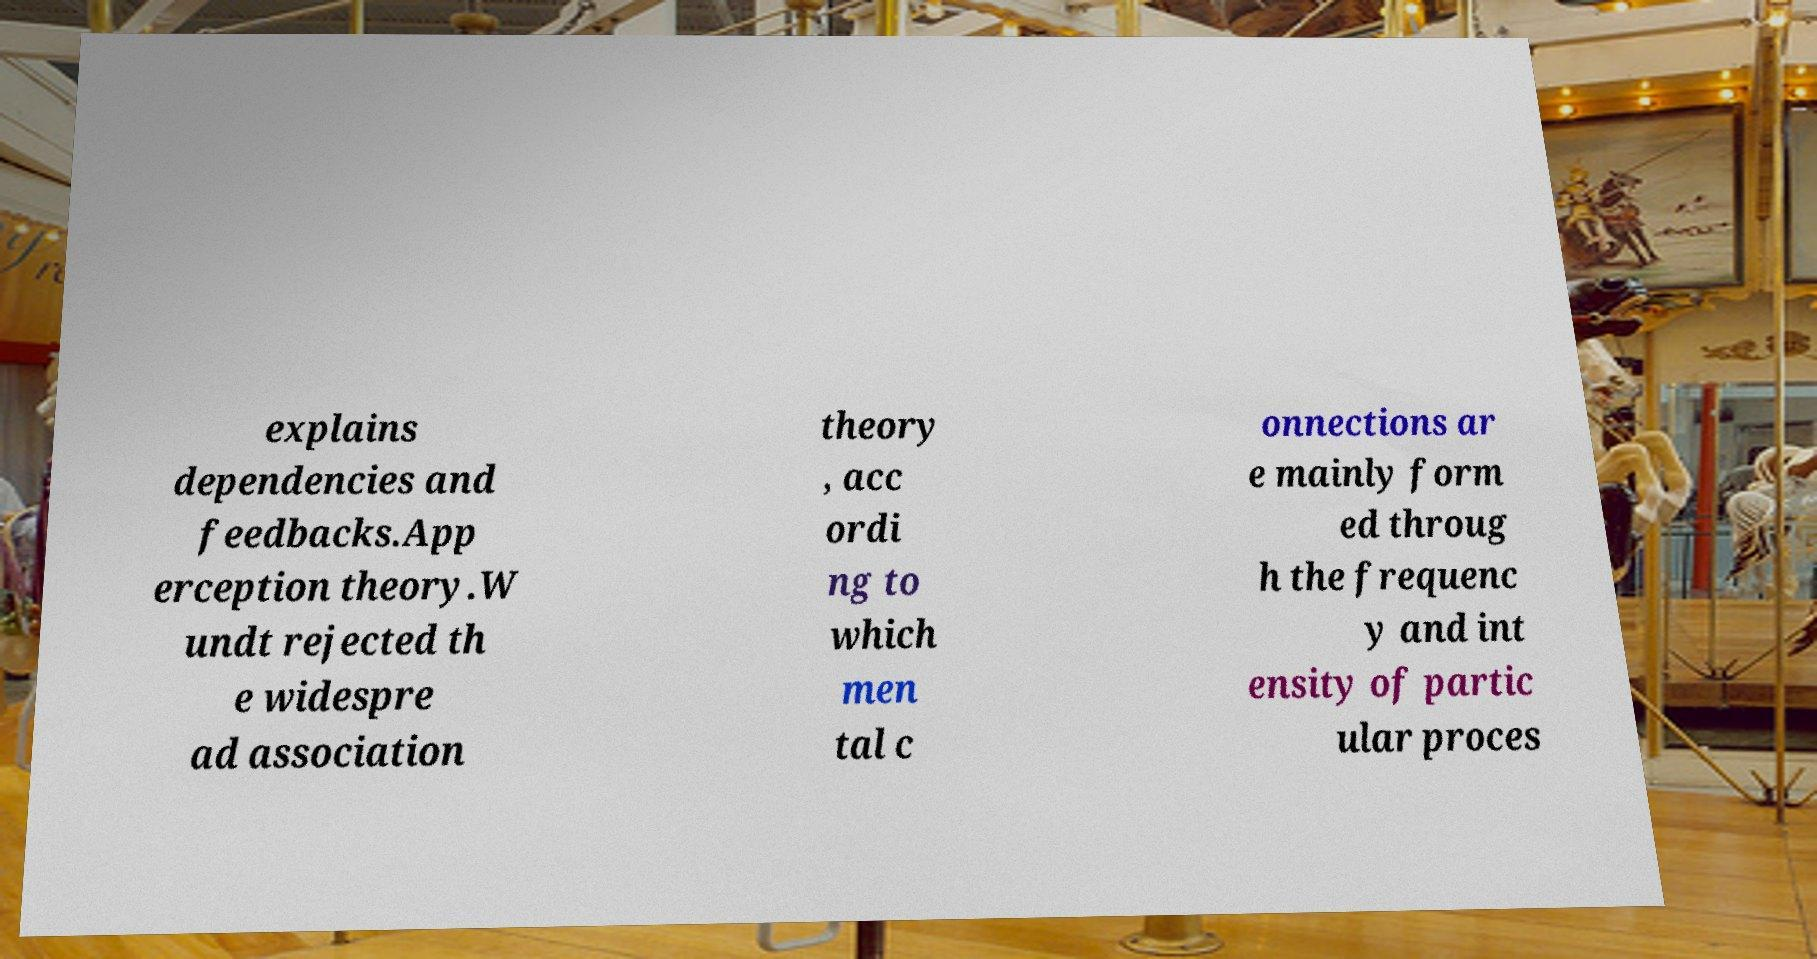For documentation purposes, I need the text within this image transcribed. Could you provide that? explains dependencies and feedbacks.App erception theory.W undt rejected th e widespre ad association theory , acc ordi ng to which men tal c onnections ar e mainly form ed throug h the frequenc y and int ensity of partic ular proces 